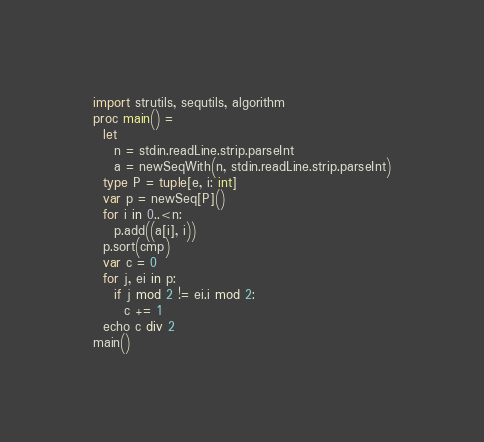Convert code to text. <code><loc_0><loc_0><loc_500><loc_500><_Nim_>import strutils, sequtils, algorithm
proc main() =
  let
    n = stdin.readLine.strip.parseInt
    a = newSeqWith(n, stdin.readLine.strip.parseInt)
  type P = tuple[e, i: int]
  var p = newSeq[P]()
  for i in 0..<n:
    p.add((a[i], i))
  p.sort(cmp)
  var c = 0
  for j, ei in p:
    if j mod 2 != ei.i mod 2:
      c += 1
  echo c div 2
main()
</code> 